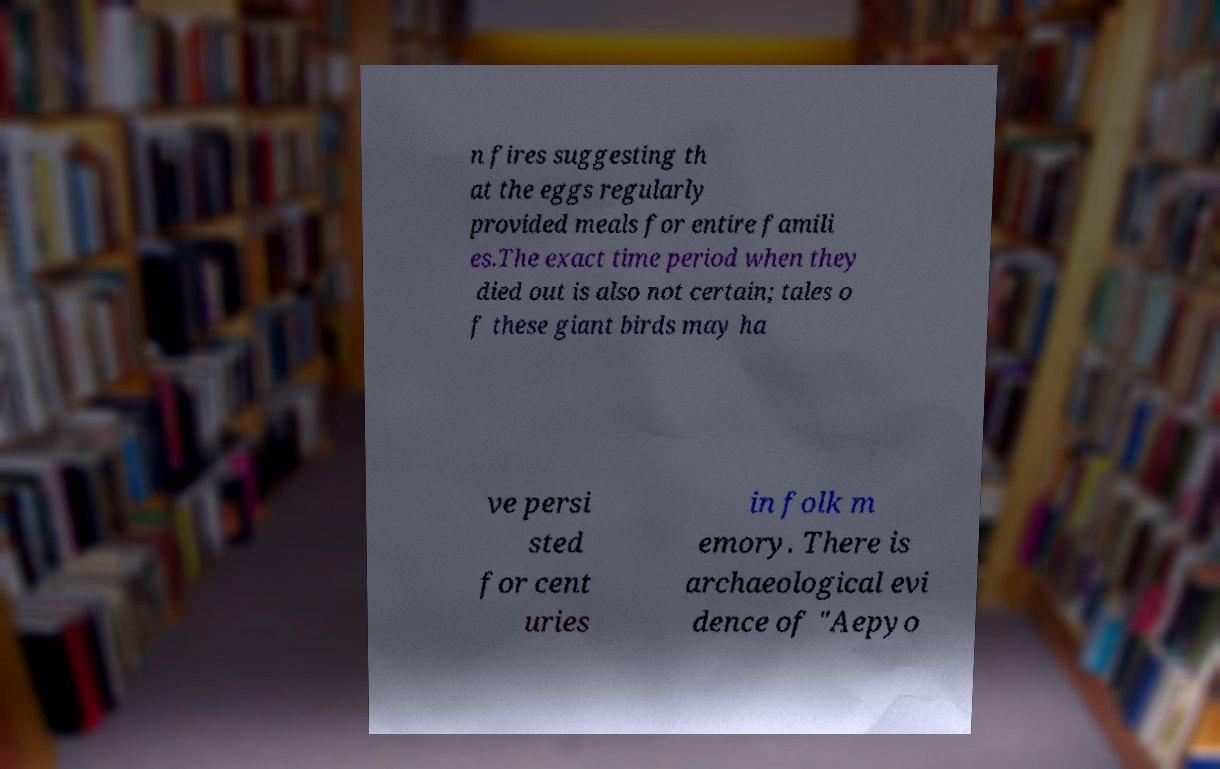Please identify and transcribe the text found in this image. n fires suggesting th at the eggs regularly provided meals for entire famili es.The exact time period when they died out is also not certain; tales o f these giant birds may ha ve persi sted for cent uries in folk m emory. There is archaeological evi dence of "Aepyo 